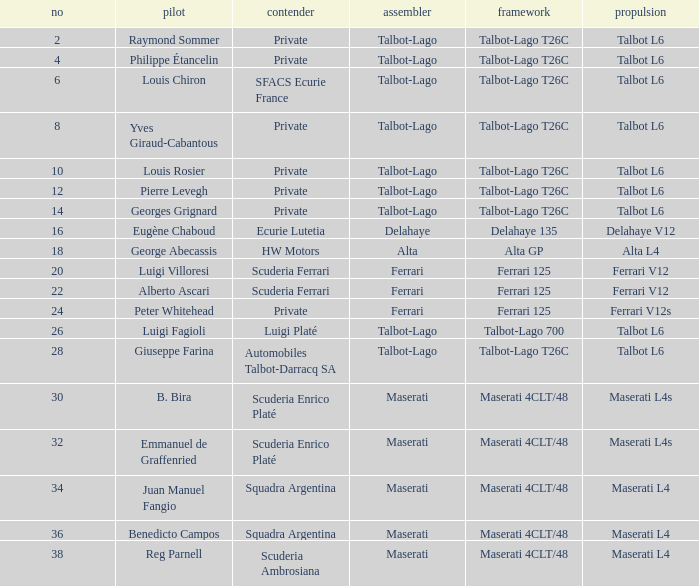Name the constructor for number 10 Talbot-Lago. Write the full table. {'header': ['no', 'pilot', 'contender', 'assembler', 'framework', 'propulsion'], 'rows': [['2', 'Raymond Sommer', 'Private', 'Talbot-Lago', 'Talbot-Lago T26C', 'Talbot L6'], ['4', 'Philippe Étancelin', 'Private', 'Talbot-Lago', 'Talbot-Lago T26C', 'Talbot L6'], ['6', 'Louis Chiron', 'SFACS Ecurie France', 'Talbot-Lago', 'Talbot-Lago T26C', 'Talbot L6'], ['8', 'Yves Giraud-Cabantous', 'Private', 'Talbot-Lago', 'Talbot-Lago T26C', 'Talbot L6'], ['10', 'Louis Rosier', 'Private', 'Talbot-Lago', 'Talbot-Lago T26C', 'Talbot L6'], ['12', 'Pierre Levegh', 'Private', 'Talbot-Lago', 'Talbot-Lago T26C', 'Talbot L6'], ['14', 'Georges Grignard', 'Private', 'Talbot-Lago', 'Talbot-Lago T26C', 'Talbot L6'], ['16', 'Eugène Chaboud', 'Ecurie Lutetia', 'Delahaye', 'Delahaye 135', 'Delahaye V12'], ['18', 'George Abecassis', 'HW Motors', 'Alta', 'Alta GP', 'Alta L4'], ['20', 'Luigi Villoresi', 'Scuderia Ferrari', 'Ferrari', 'Ferrari 125', 'Ferrari V12'], ['22', 'Alberto Ascari', 'Scuderia Ferrari', 'Ferrari', 'Ferrari 125', 'Ferrari V12'], ['24', 'Peter Whitehead', 'Private', 'Ferrari', 'Ferrari 125', 'Ferrari V12s'], ['26', 'Luigi Fagioli', 'Luigi Platé', 'Talbot-Lago', 'Talbot-Lago 700', 'Talbot L6'], ['28', 'Giuseppe Farina', 'Automobiles Talbot-Darracq SA', 'Talbot-Lago', 'Talbot-Lago T26C', 'Talbot L6'], ['30', 'B. Bira', 'Scuderia Enrico Platé', 'Maserati', 'Maserati 4CLT/48', 'Maserati L4s'], ['32', 'Emmanuel de Graffenried', 'Scuderia Enrico Platé', 'Maserati', 'Maserati 4CLT/48', 'Maserati L4s'], ['34', 'Juan Manuel Fangio', 'Squadra Argentina', 'Maserati', 'Maserati 4CLT/48', 'Maserati L4'], ['36', 'Benedicto Campos', 'Squadra Argentina', 'Maserati', 'Maserati 4CLT/48', 'Maserati L4'], ['38', 'Reg Parnell', 'Scuderia Ambrosiana', 'Maserati', 'Maserati 4CLT/48', 'Maserati L4']]} 